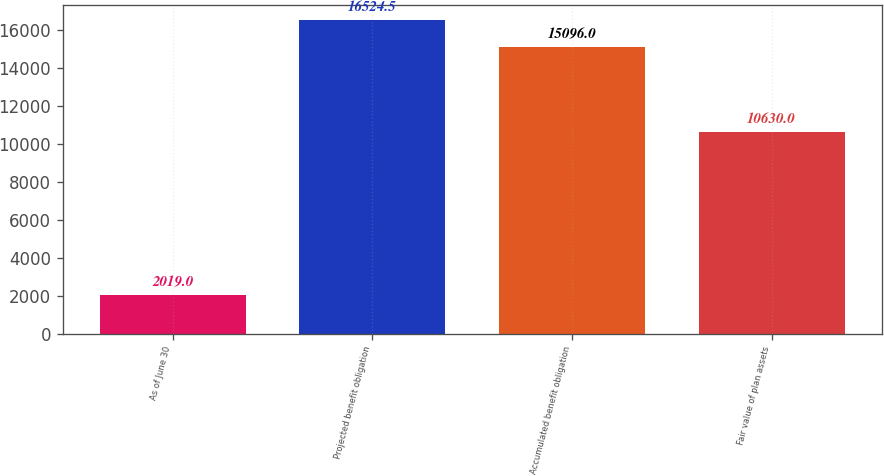<chart> <loc_0><loc_0><loc_500><loc_500><bar_chart><fcel>As of June 30<fcel>Projected benefit obligation<fcel>Accumulated benefit obligation<fcel>Fair value of plan assets<nl><fcel>2019<fcel>16524.5<fcel>15096<fcel>10630<nl></chart> 